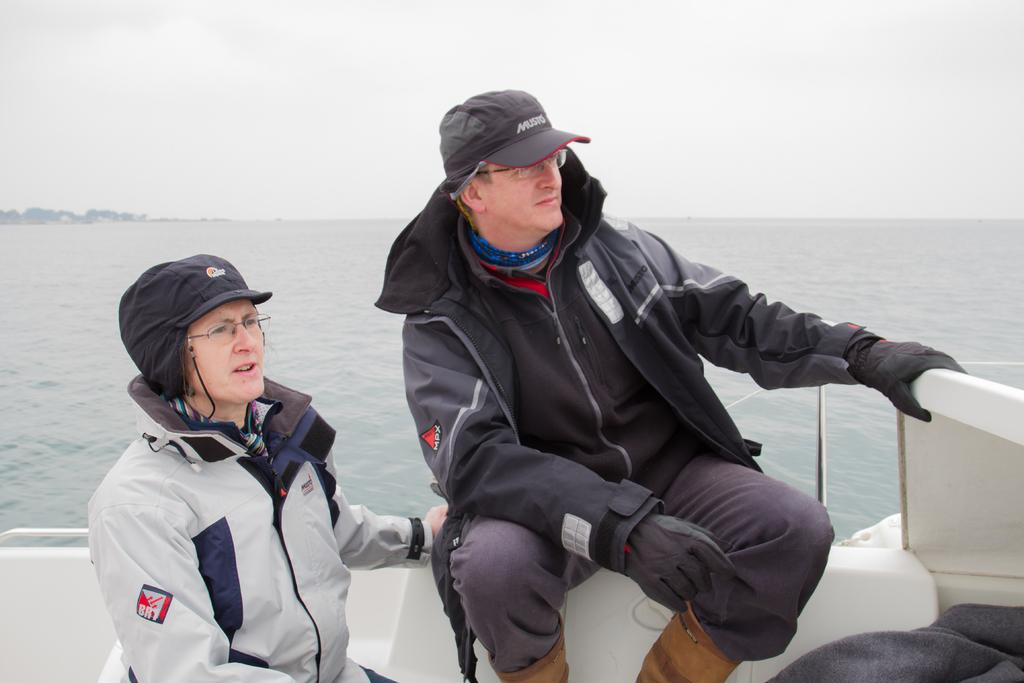How many people are in the image? There are two people in the image. What are the two people doing in the image? The two people are in a boat. Where is the boat located in the image? The boat is in the water. What can be seen in the background of the image? Trees and the sky are visible in the image. What type of iron is being used by the dad in the image? There is no dad or iron present in the image. The image features two people in a boat, with no mention of a dad or any iron-related activity. 